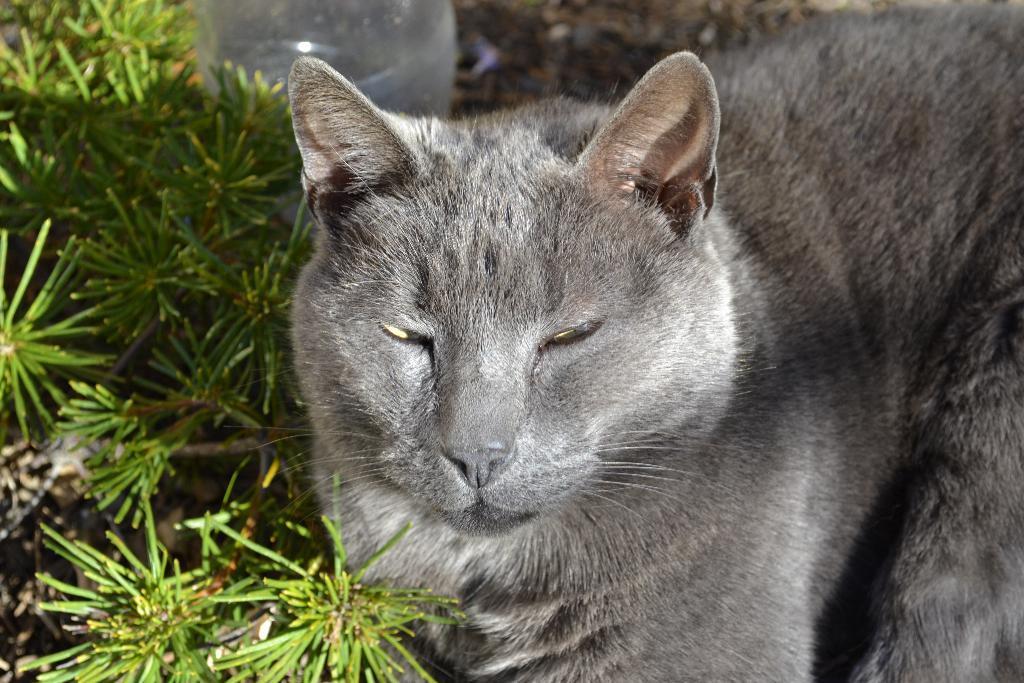Can you describe this image briefly? In this picture there is a cat which is in grey in color. Towards the left, there are plants. 